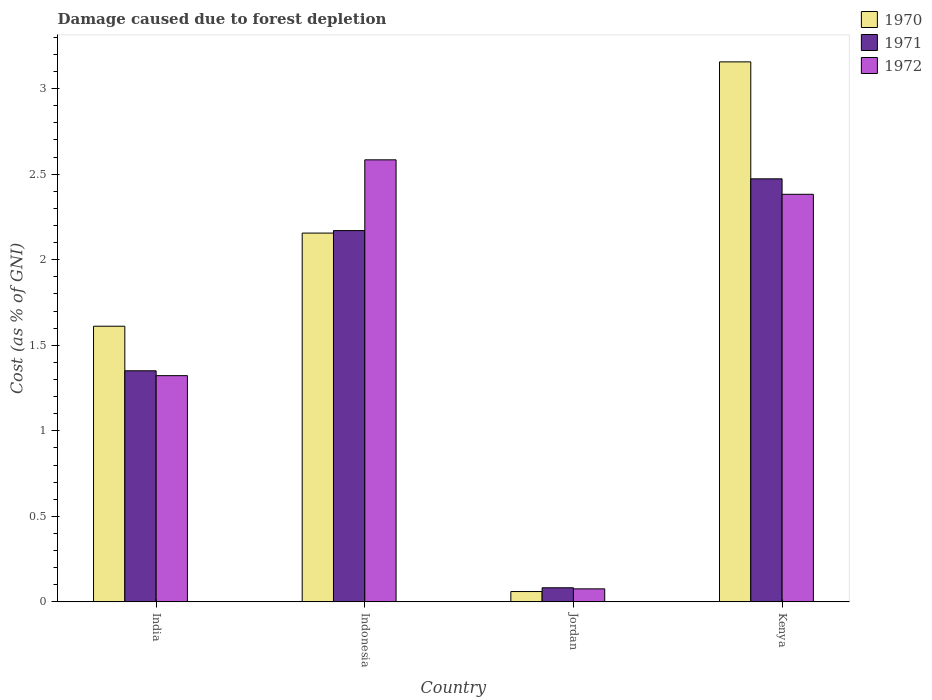How many groups of bars are there?
Ensure brevity in your answer.  4. Are the number of bars on each tick of the X-axis equal?
Make the answer very short. Yes. How many bars are there on the 4th tick from the left?
Offer a terse response. 3. How many bars are there on the 1st tick from the right?
Make the answer very short. 3. What is the label of the 3rd group of bars from the left?
Your answer should be compact. Jordan. What is the cost of damage caused due to forest depletion in 1972 in Indonesia?
Make the answer very short. 2.58. Across all countries, what is the maximum cost of damage caused due to forest depletion in 1972?
Your answer should be very brief. 2.58. Across all countries, what is the minimum cost of damage caused due to forest depletion in 1972?
Ensure brevity in your answer.  0.08. In which country was the cost of damage caused due to forest depletion in 1971 minimum?
Provide a succinct answer. Jordan. What is the total cost of damage caused due to forest depletion in 1971 in the graph?
Ensure brevity in your answer.  6.08. What is the difference between the cost of damage caused due to forest depletion in 1972 in Indonesia and that in Kenya?
Ensure brevity in your answer.  0.2. What is the difference between the cost of damage caused due to forest depletion in 1971 in Kenya and the cost of damage caused due to forest depletion in 1970 in India?
Your response must be concise. 0.86. What is the average cost of damage caused due to forest depletion in 1972 per country?
Offer a terse response. 1.59. What is the difference between the cost of damage caused due to forest depletion of/in 1972 and cost of damage caused due to forest depletion of/in 1971 in Jordan?
Your response must be concise. -0.01. What is the ratio of the cost of damage caused due to forest depletion in 1972 in Jordan to that in Kenya?
Your answer should be very brief. 0.03. Is the difference between the cost of damage caused due to forest depletion in 1972 in India and Kenya greater than the difference between the cost of damage caused due to forest depletion in 1971 in India and Kenya?
Your answer should be compact. Yes. What is the difference between the highest and the second highest cost of damage caused due to forest depletion in 1971?
Offer a very short reply. -1.12. What is the difference between the highest and the lowest cost of damage caused due to forest depletion in 1970?
Ensure brevity in your answer.  3.1. Is the sum of the cost of damage caused due to forest depletion in 1971 in Indonesia and Jordan greater than the maximum cost of damage caused due to forest depletion in 1972 across all countries?
Your answer should be very brief. No. What does the 3rd bar from the right in Kenya represents?
Your response must be concise. 1970. Are all the bars in the graph horizontal?
Provide a succinct answer. No. What is the difference between two consecutive major ticks on the Y-axis?
Give a very brief answer. 0.5. Does the graph contain any zero values?
Give a very brief answer. No. Where does the legend appear in the graph?
Provide a succinct answer. Top right. What is the title of the graph?
Keep it short and to the point. Damage caused due to forest depletion. What is the label or title of the Y-axis?
Make the answer very short. Cost (as % of GNI). What is the Cost (as % of GNI) of 1970 in India?
Ensure brevity in your answer.  1.61. What is the Cost (as % of GNI) of 1971 in India?
Provide a short and direct response. 1.35. What is the Cost (as % of GNI) in 1972 in India?
Keep it short and to the point. 1.32. What is the Cost (as % of GNI) of 1970 in Indonesia?
Your answer should be very brief. 2.16. What is the Cost (as % of GNI) in 1971 in Indonesia?
Your answer should be compact. 2.17. What is the Cost (as % of GNI) of 1972 in Indonesia?
Give a very brief answer. 2.58. What is the Cost (as % of GNI) in 1970 in Jordan?
Your answer should be very brief. 0.06. What is the Cost (as % of GNI) of 1971 in Jordan?
Your response must be concise. 0.08. What is the Cost (as % of GNI) of 1972 in Jordan?
Keep it short and to the point. 0.08. What is the Cost (as % of GNI) in 1970 in Kenya?
Your response must be concise. 3.16. What is the Cost (as % of GNI) in 1971 in Kenya?
Offer a very short reply. 2.47. What is the Cost (as % of GNI) in 1972 in Kenya?
Provide a short and direct response. 2.38. Across all countries, what is the maximum Cost (as % of GNI) in 1970?
Make the answer very short. 3.16. Across all countries, what is the maximum Cost (as % of GNI) of 1971?
Offer a terse response. 2.47. Across all countries, what is the maximum Cost (as % of GNI) of 1972?
Give a very brief answer. 2.58. Across all countries, what is the minimum Cost (as % of GNI) of 1970?
Provide a succinct answer. 0.06. Across all countries, what is the minimum Cost (as % of GNI) of 1971?
Your response must be concise. 0.08. Across all countries, what is the minimum Cost (as % of GNI) of 1972?
Make the answer very short. 0.08. What is the total Cost (as % of GNI) of 1970 in the graph?
Give a very brief answer. 6.98. What is the total Cost (as % of GNI) of 1971 in the graph?
Ensure brevity in your answer.  6.08. What is the total Cost (as % of GNI) in 1972 in the graph?
Offer a terse response. 6.37. What is the difference between the Cost (as % of GNI) of 1970 in India and that in Indonesia?
Provide a succinct answer. -0.54. What is the difference between the Cost (as % of GNI) in 1971 in India and that in Indonesia?
Keep it short and to the point. -0.82. What is the difference between the Cost (as % of GNI) of 1972 in India and that in Indonesia?
Your response must be concise. -1.26. What is the difference between the Cost (as % of GNI) in 1970 in India and that in Jordan?
Your response must be concise. 1.55. What is the difference between the Cost (as % of GNI) in 1971 in India and that in Jordan?
Ensure brevity in your answer.  1.27. What is the difference between the Cost (as % of GNI) of 1972 in India and that in Jordan?
Make the answer very short. 1.25. What is the difference between the Cost (as % of GNI) of 1970 in India and that in Kenya?
Keep it short and to the point. -1.55. What is the difference between the Cost (as % of GNI) of 1971 in India and that in Kenya?
Your answer should be very brief. -1.12. What is the difference between the Cost (as % of GNI) of 1972 in India and that in Kenya?
Your answer should be very brief. -1.06. What is the difference between the Cost (as % of GNI) of 1970 in Indonesia and that in Jordan?
Keep it short and to the point. 2.1. What is the difference between the Cost (as % of GNI) of 1971 in Indonesia and that in Jordan?
Offer a terse response. 2.09. What is the difference between the Cost (as % of GNI) of 1972 in Indonesia and that in Jordan?
Your answer should be very brief. 2.51. What is the difference between the Cost (as % of GNI) of 1970 in Indonesia and that in Kenya?
Ensure brevity in your answer.  -1. What is the difference between the Cost (as % of GNI) in 1971 in Indonesia and that in Kenya?
Make the answer very short. -0.3. What is the difference between the Cost (as % of GNI) of 1972 in Indonesia and that in Kenya?
Your answer should be compact. 0.2. What is the difference between the Cost (as % of GNI) in 1970 in Jordan and that in Kenya?
Make the answer very short. -3.1. What is the difference between the Cost (as % of GNI) in 1971 in Jordan and that in Kenya?
Provide a succinct answer. -2.39. What is the difference between the Cost (as % of GNI) of 1972 in Jordan and that in Kenya?
Ensure brevity in your answer.  -2.31. What is the difference between the Cost (as % of GNI) of 1970 in India and the Cost (as % of GNI) of 1971 in Indonesia?
Your answer should be compact. -0.56. What is the difference between the Cost (as % of GNI) of 1970 in India and the Cost (as % of GNI) of 1972 in Indonesia?
Offer a very short reply. -0.97. What is the difference between the Cost (as % of GNI) in 1971 in India and the Cost (as % of GNI) in 1972 in Indonesia?
Provide a short and direct response. -1.23. What is the difference between the Cost (as % of GNI) of 1970 in India and the Cost (as % of GNI) of 1971 in Jordan?
Provide a succinct answer. 1.53. What is the difference between the Cost (as % of GNI) of 1970 in India and the Cost (as % of GNI) of 1972 in Jordan?
Your answer should be compact. 1.54. What is the difference between the Cost (as % of GNI) in 1971 in India and the Cost (as % of GNI) in 1972 in Jordan?
Provide a succinct answer. 1.27. What is the difference between the Cost (as % of GNI) of 1970 in India and the Cost (as % of GNI) of 1971 in Kenya?
Your answer should be compact. -0.86. What is the difference between the Cost (as % of GNI) in 1970 in India and the Cost (as % of GNI) in 1972 in Kenya?
Give a very brief answer. -0.77. What is the difference between the Cost (as % of GNI) in 1971 in India and the Cost (as % of GNI) in 1972 in Kenya?
Your answer should be compact. -1.03. What is the difference between the Cost (as % of GNI) in 1970 in Indonesia and the Cost (as % of GNI) in 1971 in Jordan?
Your answer should be very brief. 2.07. What is the difference between the Cost (as % of GNI) in 1970 in Indonesia and the Cost (as % of GNI) in 1972 in Jordan?
Your answer should be very brief. 2.08. What is the difference between the Cost (as % of GNI) in 1971 in Indonesia and the Cost (as % of GNI) in 1972 in Jordan?
Offer a terse response. 2.09. What is the difference between the Cost (as % of GNI) in 1970 in Indonesia and the Cost (as % of GNI) in 1971 in Kenya?
Give a very brief answer. -0.32. What is the difference between the Cost (as % of GNI) of 1970 in Indonesia and the Cost (as % of GNI) of 1972 in Kenya?
Offer a very short reply. -0.23. What is the difference between the Cost (as % of GNI) in 1971 in Indonesia and the Cost (as % of GNI) in 1972 in Kenya?
Offer a very short reply. -0.21. What is the difference between the Cost (as % of GNI) of 1970 in Jordan and the Cost (as % of GNI) of 1971 in Kenya?
Your response must be concise. -2.41. What is the difference between the Cost (as % of GNI) in 1970 in Jordan and the Cost (as % of GNI) in 1972 in Kenya?
Give a very brief answer. -2.32. What is the difference between the Cost (as % of GNI) in 1971 in Jordan and the Cost (as % of GNI) in 1972 in Kenya?
Your answer should be very brief. -2.3. What is the average Cost (as % of GNI) in 1970 per country?
Give a very brief answer. 1.75. What is the average Cost (as % of GNI) in 1971 per country?
Make the answer very short. 1.52. What is the average Cost (as % of GNI) in 1972 per country?
Make the answer very short. 1.59. What is the difference between the Cost (as % of GNI) of 1970 and Cost (as % of GNI) of 1971 in India?
Make the answer very short. 0.26. What is the difference between the Cost (as % of GNI) of 1970 and Cost (as % of GNI) of 1972 in India?
Make the answer very short. 0.29. What is the difference between the Cost (as % of GNI) of 1971 and Cost (as % of GNI) of 1972 in India?
Offer a terse response. 0.03. What is the difference between the Cost (as % of GNI) in 1970 and Cost (as % of GNI) in 1971 in Indonesia?
Ensure brevity in your answer.  -0.01. What is the difference between the Cost (as % of GNI) in 1970 and Cost (as % of GNI) in 1972 in Indonesia?
Your response must be concise. -0.43. What is the difference between the Cost (as % of GNI) in 1971 and Cost (as % of GNI) in 1972 in Indonesia?
Make the answer very short. -0.41. What is the difference between the Cost (as % of GNI) in 1970 and Cost (as % of GNI) in 1971 in Jordan?
Keep it short and to the point. -0.02. What is the difference between the Cost (as % of GNI) in 1970 and Cost (as % of GNI) in 1972 in Jordan?
Offer a terse response. -0.02. What is the difference between the Cost (as % of GNI) of 1971 and Cost (as % of GNI) of 1972 in Jordan?
Your answer should be compact. 0.01. What is the difference between the Cost (as % of GNI) in 1970 and Cost (as % of GNI) in 1971 in Kenya?
Your response must be concise. 0.68. What is the difference between the Cost (as % of GNI) in 1970 and Cost (as % of GNI) in 1972 in Kenya?
Keep it short and to the point. 0.77. What is the difference between the Cost (as % of GNI) in 1971 and Cost (as % of GNI) in 1972 in Kenya?
Keep it short and to the point. 0.09. What is the ratio of the Cost (as % of GNI) of 1970 in India to that in Indonesia?
Offer a very short reply. 0.75. What is the ratio of the Cost (as % of GNI) of 1971 in India to that in Indonesia?
Your answer should be very brief. 0.62. What is the ratio of the Cost (as % of GNI) of 1972 in India to that in Indonesia?
Make the answer very short. 0.51. What is the ratio of the Cost (as % of GNI) in 1970 in India to that in Jordan?
Your answer should be very brief. 26.69. What is the ratio of the Cost (as % of GNI) of 1971 in India to that in Jordan?
Your answer should be very brief. 16.38. What is the ratio of the Cost (as % of GNI) in 1972 in India to that in Jordan?
Ensure brevity in your answer.  17.38. What is the ratio of the Cost (as % of GNI) in 1970 in India to that in Kenya?
Offer a very short reply. 0.51. What is the ratio of the Cost (as % of GNI) of 1971 in India to that in Kenya?
Give a very brief answer. 0.55. What is the ratio of the Cost (as % of GNI) of 1972 in India to that in Kenya?
Make the answer very short. 0.56. What is the ratio of the Cost (as % of GNI) of 1970 in Indonesia to that in Jordan?
Keep it short and to the point. 35.71. What is the ratio of the Cost (as % of GNI) of 1971 in Indonesia to that in Jordan?
Provide a succinct answer. 26.32. What is the ratio of the Cost (as % of GNI) in 1972 in Indonesia to that in Jordan?
Keep it short and to the point. 33.95. What is the ratio of the Cost (as % of GNI) in 1970 in Indonesia to that in Kenya?
Offer a terse response. 0.68. What is the ratio of the Cost (as % of GNI) of 1971 in Indonesia to that in Kenya?
Provide a succinct answer. 0.88. What is the ratio of the Cost (as % of GNI) of 1972 in Indonesia to that in Kenya?
Your response must be concise. 1.08. What is the ratio of the Cost (as % of GNI) of 1970 in Jordan to that in Kenya?
Make the answer very short. 0.02. What is the ratio of the Cost (as % of GNI) in 1972 in Jordan to that in Kenya?
Provide a succinct answer. 0.03. What is the difference between the highest and the second highest Cost (as % of GNI) of 1971?
Ensure brevity in your answer.  0.3. What is the difference between the highest and the second highest Cost (as % of GNI) of 1972?
Your response must be concise. 0.2. What is the difference between the highest and the lowest Cost (as % of GNI) in 1970?
Your answer should be compact. 3.1. What is the difference between the highest and the lowest Cost (as % of GNI) in 1971?
Offer a very short reply. 2.39. What is the difference between the highest and the lowest Cost (as % of GNI) of 1972?
Offer a terse response. 2.51. 